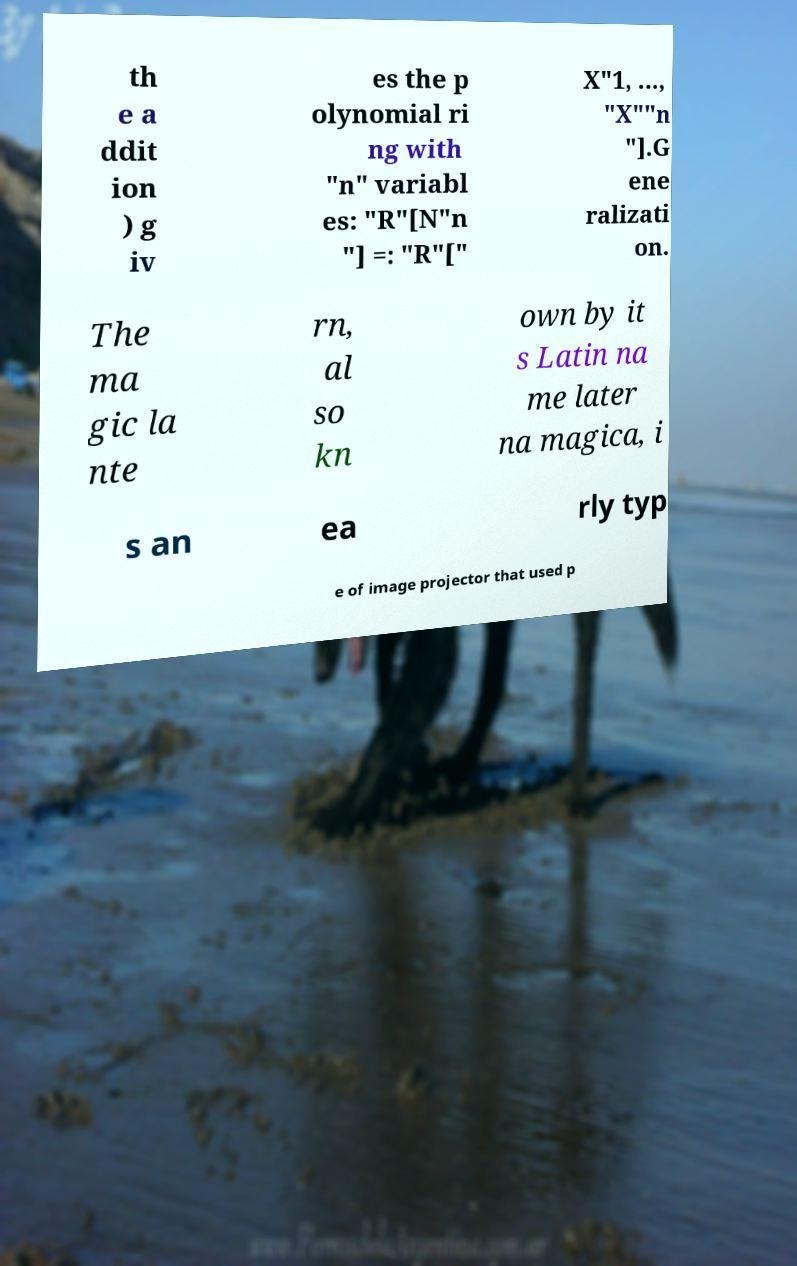Please read and relay the text visible in this image. What does it say? th e a ddit ion ) g iv es the p olynomial ri ng with "n" variabl es: "R"[N"n "] =: "R"[" X"1, ..., "X""n "].G ene ralizati on. The ma gic la nte rn, al so kn own by it s Latin na me later na magica, i s an ea rly typ e of image projector that used p 